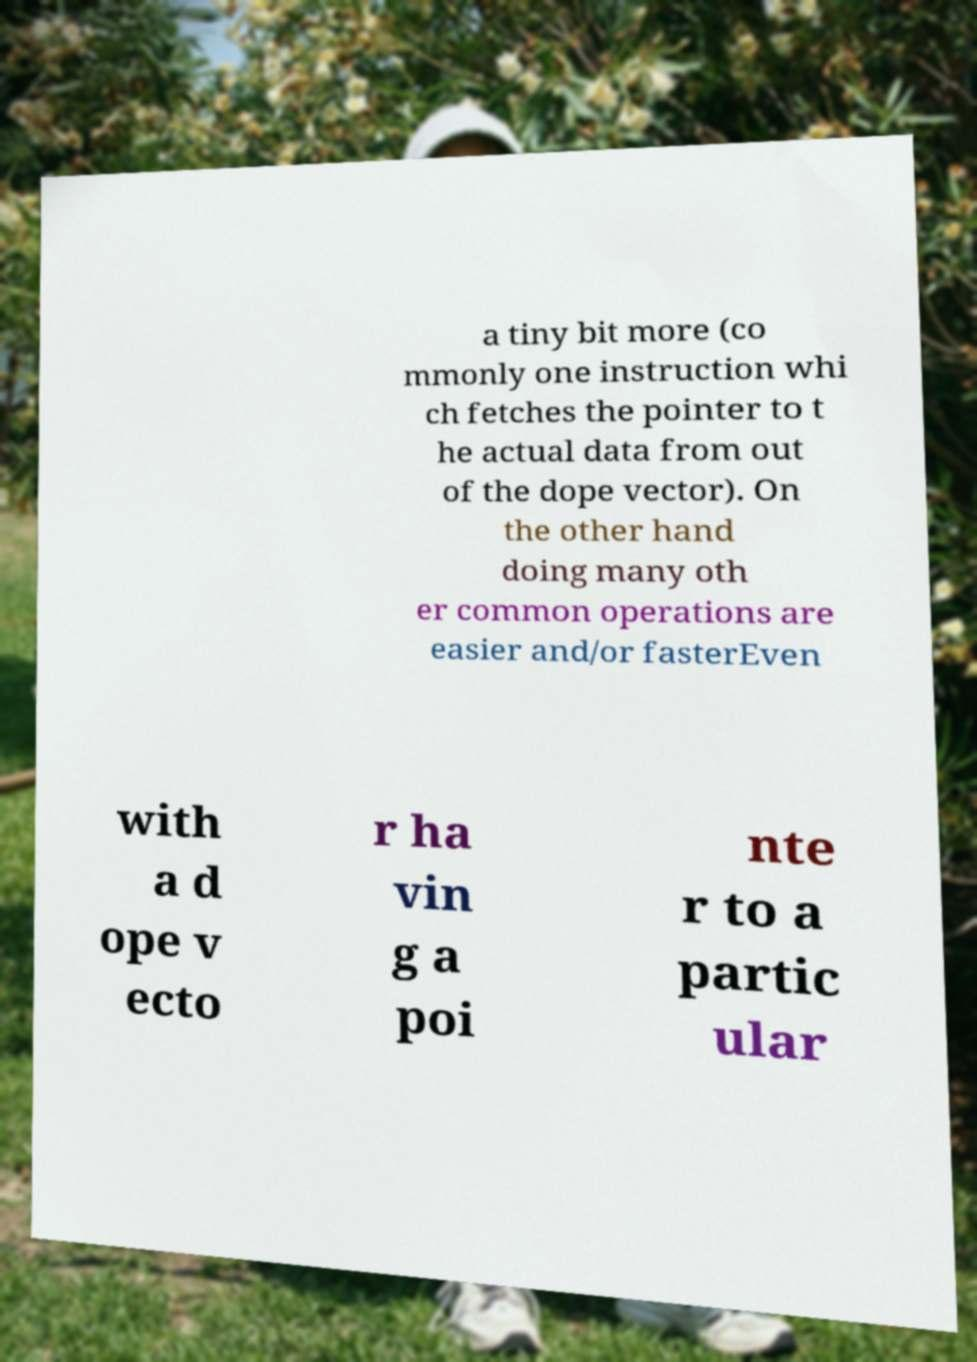Could you assist in decoding the text presented in this image and type it out clearly? a tiny bit more (co mmonly one instruction whi ch fetches the pointer to t he actual data from out of the dope vector). On the other hand doing many oth er common operations are easier and/or fasterEven with a d ope v ecto r ha vin g a poi nte r to a partic ular 